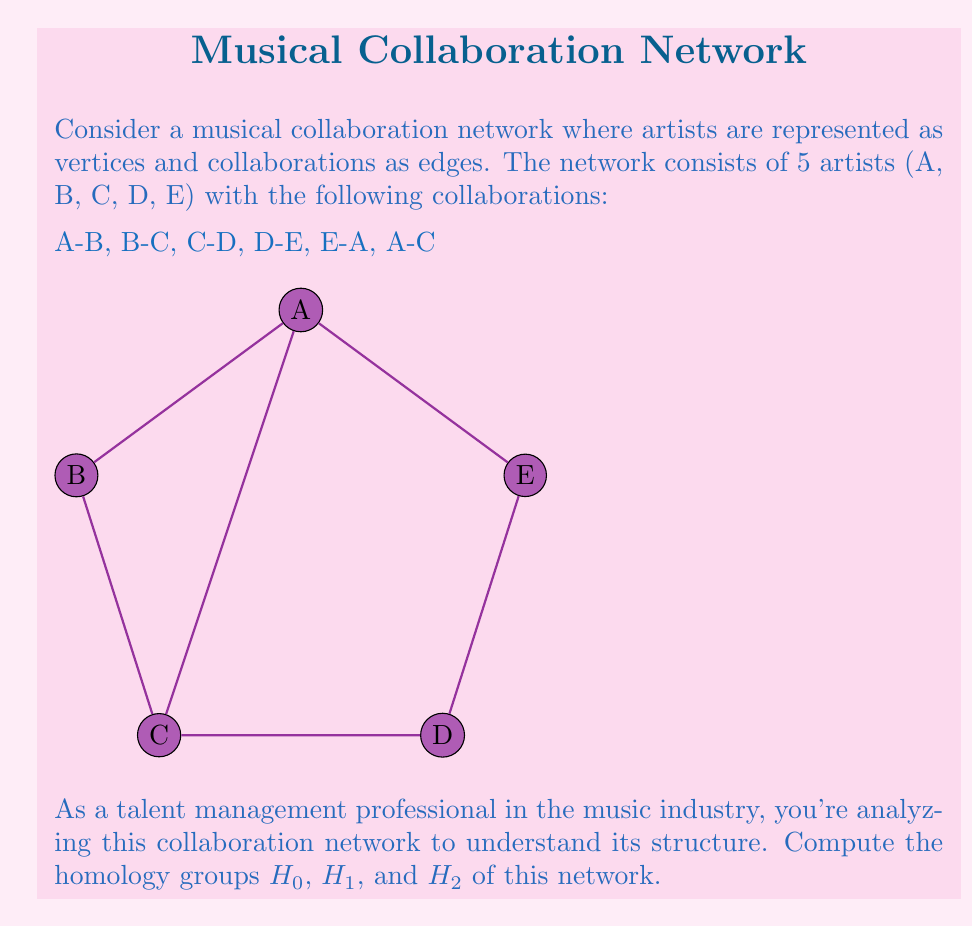What is the answer to this math problem? To compute the homology groups, we'll follow these steps:

1. Identify the simplicial complex:
   0-simplices: 5 vertices (A, B, C, D, E)
   1-simplices: 6 edges (AB, BC, CD, DE, EA, AC)
   2-simplices: 1 triangle (ACE)

2. Calculate the chain groups:
   $C_0 = \mathbb{Z}^5$ (5 vertices)
   $C_1 = \mathbb{Z}^6$ (6 edges)
   $C_2 = \mathbb{Z}^1$ (1 triangle)
   $C_k = 0$ for $k \geq 3$

3. Compute the boundary maps:
   $\partial_2: C_2 \to C_1$
   $\partial_1: C_1 \to C_0$

4. Calculate the kernel and image of each boundary map:
   $\ker(\partial_1) = \mathbb{Z}^2$ (two independent cycles: ABCDE and ACE)
   $\text{im}(\partial_2) = \mathbb{Z}^1$ (boundary of the ACE triangle)
   $\ker(\partial_0) = \mathbb{Z}^5$ (all vertices)
   $\text{im}(\partial_1) = \mathbb{Z}^4$ (spanning tree with 4 edges)

5. Compute the homology groups:
   $H_0 = \ker(\partial_0) / \text{im}(\partial_1) = \mathbb{Z}^5 / \mathbb{Z}^4 \cong \mathbb{Z}$
   $H_1 = \ker(\partial_1) / \text{im}(\partial_2) = \mathbb{Z}^2 / \mathbb{Z}^1 \cong \mathbb{Z}$
   $H_2 = \ker(\partial_2) / \text{im}(\partial_3) = 0 / 0 \cong 0$
   $H_k = 0$ for $k \geq 3$
Answer: $H_0 \cong \mathbb{Z}$, $H_1 \cong \mathbb{Z}$, $H_2 \cong 0$, $H_k \cong 0$ for $k \geq 3$ 